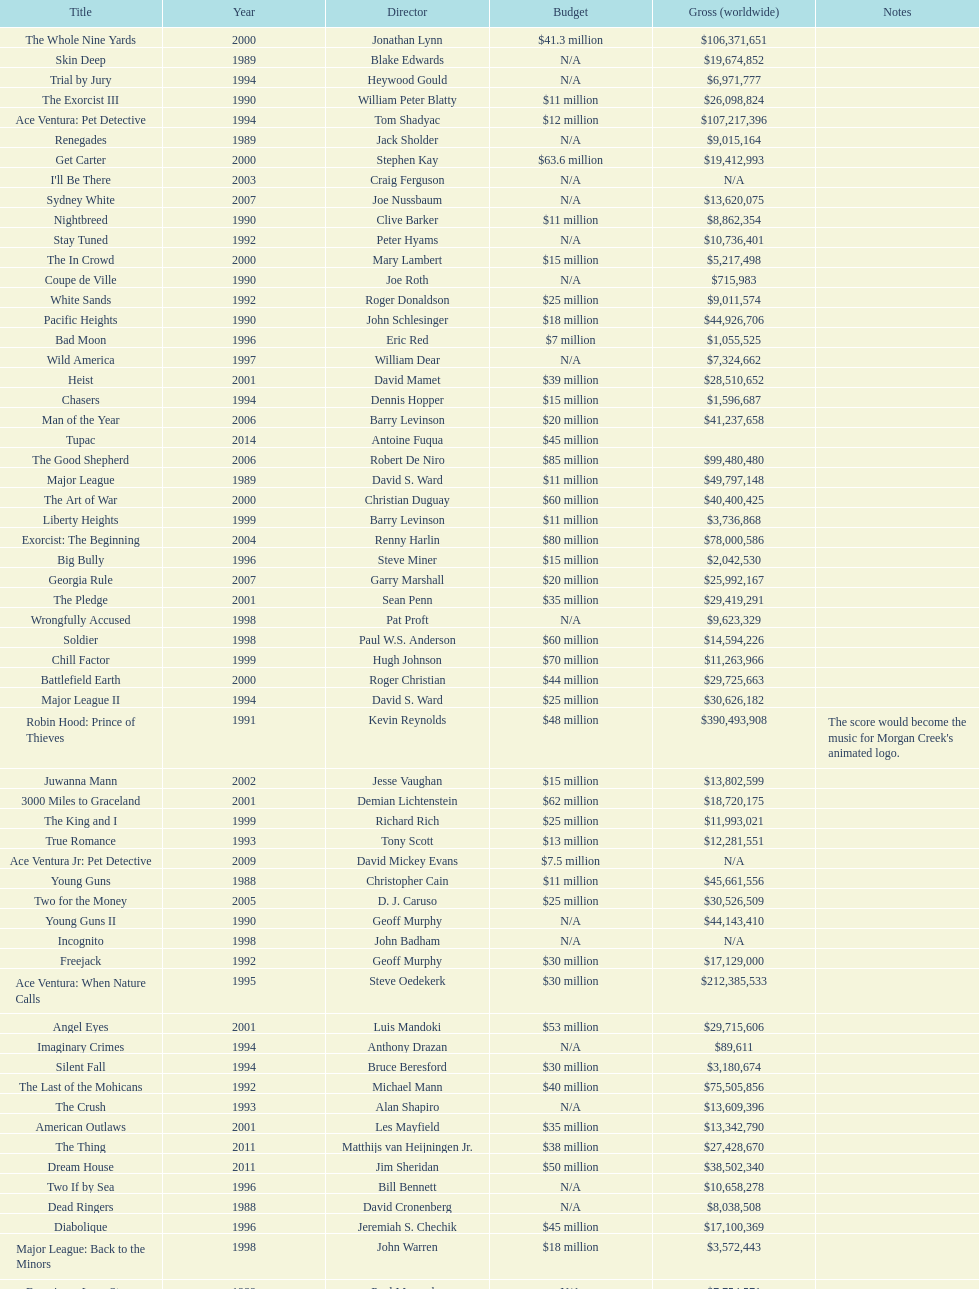Which film had a higher budget, ace ventura: when nature calls, or major league: back to the minors? Ace Ventura: When Nature Calls. Can you give me this table as a dict? {'header': ['Title', 'Year', 'Director', 'Budget', 'Gross (worldwide)', 'Notes'], 'rows': [['The Whole Nine Yards', '2000', 'Jonathan Lynn', '$41.3 million', '$106,371,651', ''], ['Skin Deep', '1989', 'Blake Edwards', 'N/A', '$19,674,852', ''], ['Trial by Jury', '1994', 'Heywood Gould', 'N/A', '$6,971,777', ''], ['The Exorcist III', '1990', 'William Peter Blatty', '$11 million', '$26,098,824', ''], ['Ace Ventura: Pet Detective', '1994', 'Tom Shadyac', '$12 million', '$107,217,396', ''], ['Renegades', '1989', 'Jack Sholder', 'N/A', '$9,015,164', ''], ['Get Carter', '2000', 'Stephen Kay', '$63.6 million', '$19,412,993', ''], ["I'll Be There", '2003', 'Craig Ferguson', 'N/A', 'N/A', ''], ['Sydney White', '2007', 'Joe Nussbaum', 'N/A', '$13,620,075', ''], ['Nightbreed', '1990', 'Clive Barker', '$11 million', '$8,862,354', ''], ['Stay Tuned', '1992', 'Peter Hyams', 'N/A', '$10,736,401', ''], ['The In Crowd', '2000', 'Mary Lambert', '$15 million', '$5,217,498', ''], ['Coupe de Ville', '1990', 'Joe Roth', 'N/A', '$715,983', ''], ['White Sands', '1992', 'Roger Donaldson', '$25 million', '$9,011,574', ''], ['Pacific Heights', '1990', 'John Schlesinger', '$18 million', '$44,926,706', ''], ['Bad Moon', '1996', 'Eric Red', '$7 million', '$1,055,525', ''], ['Wild America', '1997', 'William Dear', 'N/A', '$7,324,662', ''], ['Heist', '2001', 'David Mamet', '$39 million', '$28,510,652', ''], ['Chasers', '1994', 'Dennis Hopper', '$15 million', '$1,596,687', ''], ['Man of the Year', '2006', 'Barry Levinson', '$20 million', '$41,237,658', ''], ['Tupac', '2014', 'Antoine Fuqua', '$45 million', '', ''], ['The Good Shepherd', '2006', 'Robert De Niro', '$85 million', '$99,480,480', ''], ['Major League', '1989', 'David S. Ward', '$11 million', '$49,797,148', ''], ['The Art of War', '2000', 'Christian Duguay', '$60 million', '$40,400,425', ''], ['Liberty Heights', '1999', 'Barry Levinson', '$11 million', '$3,736,868', ''], ['Exorcist: The Beginning', '2004', 'Renny Harlin', '$80 million', '$78,000,586', ''], ['Big Bully', '1996', 'Steve Miner', '$15 million', '$2,042,530', ''], ['Georgia Rule', '2007', 'Garry Marshall', '$20 million', '$25,992,167', ''], ['The Pledge', '2001', 'Sean Penn', '$35 million', '$29,419,291', ''], ['Wrongfully Accused', '1998', 'Pat Proft', 'N/A', '$9,623,329', ''], ['Soldier', '1998', 'Paul W.S. Anderson', '$60 million', '$14,594,226', ''], ['Chill Factor', '1999', 'Hugh Johnson', '$70 million', '$11,263,966', ''], ['Battlefield Earth', '2000', 'Roger Christian', '$44 million', '$29,725,663', ''], ['Major League II', '1994', 'David S. Ward', '$25 million', '$30,626,182', ''], ['Robin Hood: Prince of Thieves', '1991', 'Kevin Reynolds', '$48 million', '$390,493,908', "The score would become the music for Morgan Creek's animated logo."], ['Juwanna Mann', '2002', 'Jesse Vaughan', '$15 million', '$13,802,599', ''], ['3000 Miles to Graceland', '2001', 'Demian Lichtenstein', '$62 million', '$18,720,175', ''], ['The King and I', '1999', 'Richard Rich', '$25 million', '$11,993,021', ''], ['True Romance', '1993', 'Tony Scott', '$13 million', '$12,281,551', ''], ['Ace Ventura Jr: Pet Detective', '2009', 'David Mickey Evans', '$7.5 million', 'N/A', ''], ['Young Guns', '1988', 'Christopher Cain', '$11 million', '$45,661,556', ''], ['Two for the Money', '2005', 'D. J. Caruso', '$25 million', '$30,526,509', ''], ['Young Guns II', '1990', 'Geoff Murphy', 'N/A', '$44,143,410', ''], ['Incognito', '1998', 'John Badham', 'N/A', 'N/A', ''], ['Freejack', '1992', 'Geoff Murphy', '$30 million', '$17,129,000', ''], ['Ace Ventura: When Nature Calls', '1995', 'Steve Oedekerk', '$30 million', '$212,385,533', ''], ['Angel Eyes', '2001', 'Luis Mandoki', '$53 million', '$29,715,606', ''], ['Imaginary Crimes', '1994', 'Anthony Drazan', 'N/A', '$89,611', ''], ['Silent Fall', '1994', 'Bruce Beresford', '$30 million', '$3,180,674', ''], ['The Last of the Mohicans', '1992', 'Michael Mann', '$40 million', '$75,505,856', ''], ['The Crush', '1993', 'Alan Shapiro', 'N/A', '$13,609,396', ''], ['American Outlaws', '2001', 'Les Mayfield', '$35 million', '$13,342,790', ''], ['The Thing', '2011', 'Matthijs van Heijningen Jr.', '$38 million', '$27,428,670', ''], ['Dream House', '2011', 'Jim Sheridan', '$50 million', '$38,502,340', ''], ['Two If by Sea', '1996', 'Bill Bennett', 'N/A', '$10,658,278', ''], ['Dead Ringers', '1988', 'David Cronenberg', 'N/A', '$8,038,508', ''], ['Diabolique', '1996', 'Jeremiah S. Chechik', '$45 million', '$17,100,369', ''], ['Major League: Back to the Minors', '1998', 'John Warren', '$18 million', '$3,572,443', ''], ['Enemies, a Love Story', '1989', 'Paul Mazursky', 'N/A', '$7,754,571', ''], ['Dominion: Prequel to the Exorcist', '2005', 'Paul Schrader', '$30 million', '$251,495', '']]} 